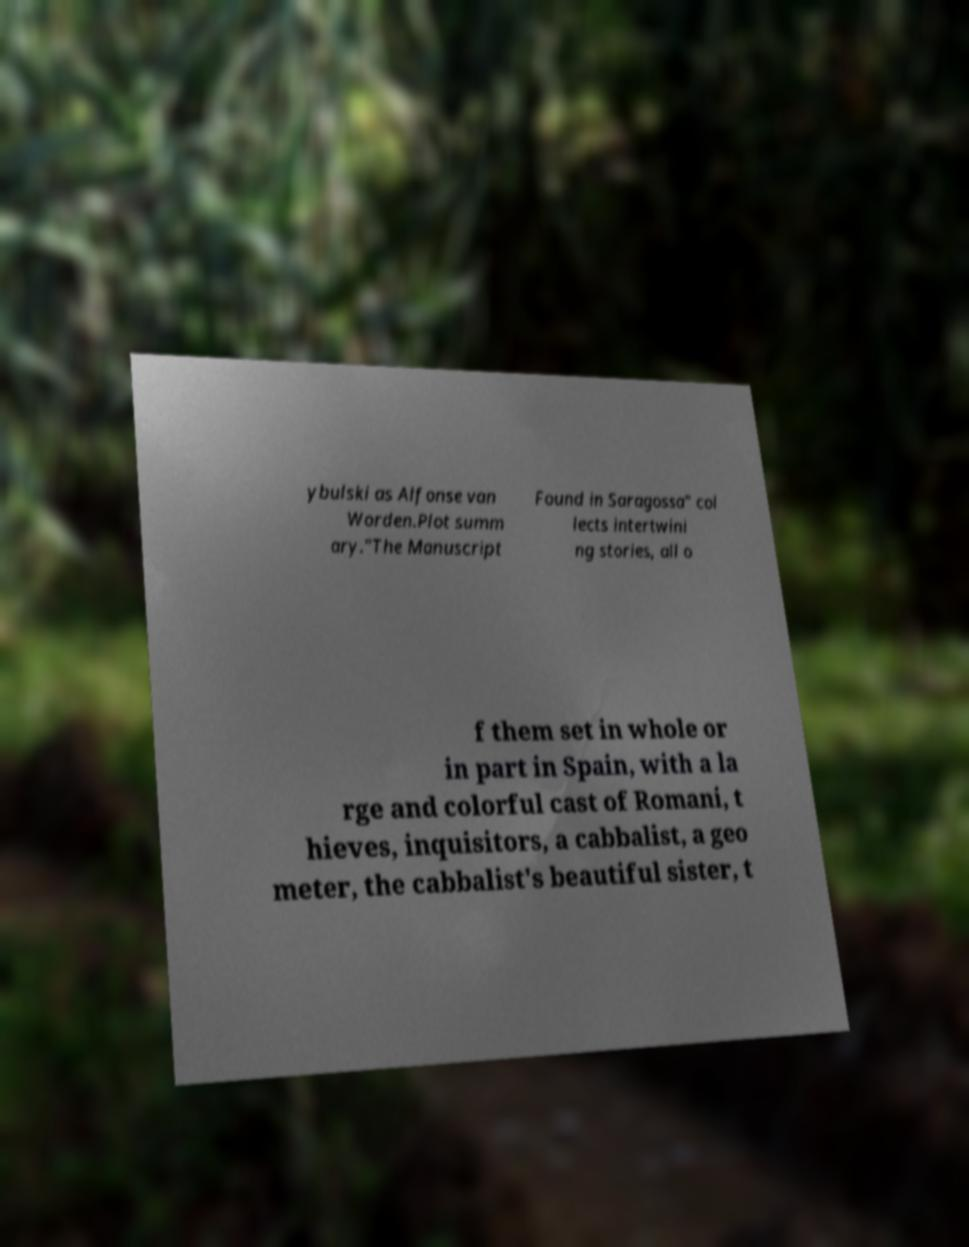I need the written content from this picture converted into text. Can you do that? ybulski as Alfonse van Worden.Plot summ ary."The Manuscript Found in Saragossa" col lects intertwini ng stories, all o f them set in whole or in part in Spain, with a la rge and colorful cast of Romani, t hieves, inquisitors, a cabbalist, a geo meter, the cabbalist's beautiful sister, t 